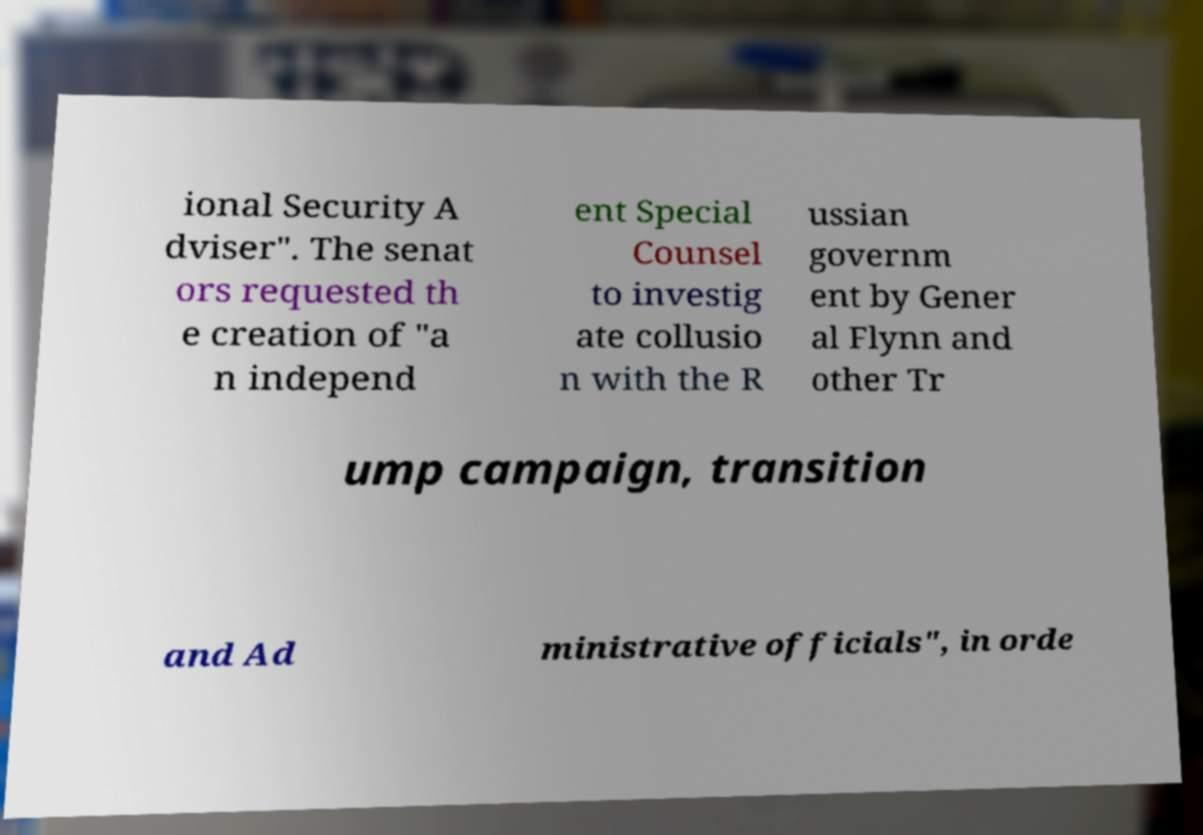Please identify and transcribe the text found in this image. ional Security A dviser". The senat ors requested th e creation of "a n independ ent Special Counsel to investig ate collusio n with the R ussian governm ent by Gener al Flynn and other Tr ump campaign, transition and Ad ministrative officials", in orde 